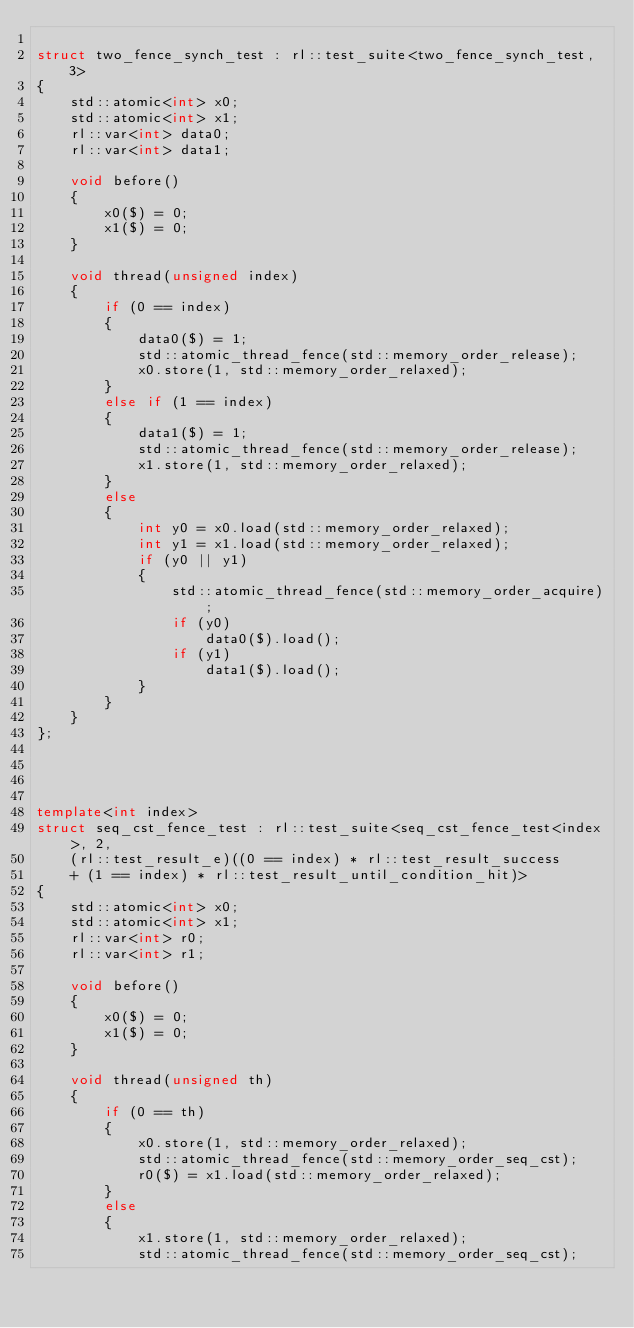<code> <loc_0><loc_0><loc_500><loc_500><_C++_>
struct two_fence_synch_test : rl::test_suite<two_fence_synch_test, 3>
{
    std::atomic<int> x0;
    std::atomic<int> x1;
    rl::var<int> data0;
    rl::var<int> data1;

    void before()
    {
        x0($) = 0;
        x1($) = 0;
    }

    void thread(unsigned index)
    {
        if (0 == index)
        {
            data0($) = 1;
            std::atomic_thread_fence(std::memory_order_release);
            x0.store(1, std::memory_order_relaxed);
        }
        else if (1 == index)
        {
            data1($) = 1;
            std::atomic_thread_fence(std::memory_order_release);
            x1.store(1, std::memory_order_relaxed);
        }
        else
        {
            int y0 = x0.load(std::memory_order_relaxed);
            int y1 = x1.load(std::memory_order_relaxed);
            if (y0 || y1)
            {
                std::atomic_thread_fence(std::memory_order_acquire);
                if (y0)
                    data0($).load();
                if (y1)
                    data1($).load();
            }
        }
    }
};




template<int index>
struct seq_cst_fence_test : rl::test_suite<seq_cst_fence_test<index>, 2,
    (rl::test_result_e)((0 == index) * rl::test_result_success
    + (1 == index) * rl::test_result_until_condition_hit)>
{
    std::atomic<int> x0;
    std::atomic<int> x1;
    rl::var<int> r0;
    rl::var<int> r1;

    void before()
    {
        x0($) = 0;
        x1($) = 0;
    }

    void thread(unsigned th)
    {
        if (0 == th)
        {
            x0.store(1, std::memory_order_relaxed);
            std::atomic_thread_fence(std::memory_order_seq_cst);
            r0($) = x1.load(std::memory_order_relaxed);
        }
        else
        {
            x1.store(1, std::memory_order_relaxed);
            std::atomic_thread_fence(std::memory_order_seq_cst);</code> 